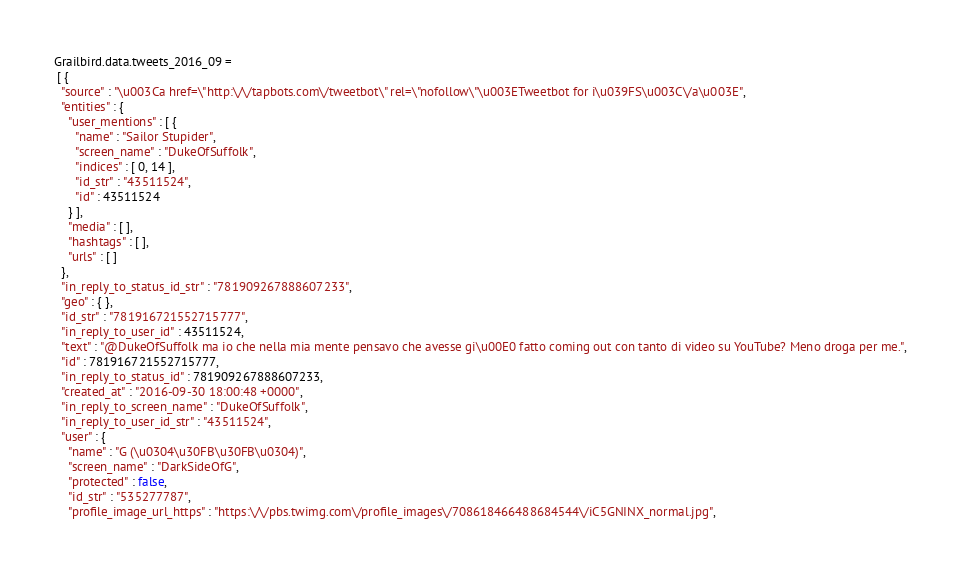<code> <loc_0><loc_0><loc_500><loc_500><_JavaScript_>Grailbird.data.tweets_2016_09 = 
 [ {
  "source" : "\u003Ca href=\"http:\/\/tapbots.com\/tweetbot\" rel=\"nofollow\"\u003ETweetbot for i\u039FS\u003C\/a\u003E",
  "entities" : {
    "user_mentions" : [ {
      "name" : "Sailor Stupider",
      "screen_name" : "DukeOfSuffolk",
      "indices" : [ 0, 14 ],
      "id_str" : "43511524",
      "id" : 43511524
    } ],
    "media" : [ ],
    "hashtags" : [ ],
    "urls" : [ ]
  },
  "in_reply_to_status_id_str" : "781909267888607233",
  "geo" : { },
  "id_str" : "781916721552715777",
  "in_reply_to_user_id" : 43511524,
  "text" : "@DukeOfSuffolk ma io che nella mia mente pensavo che avesse gi\u00E0 fatto coming out con tanto di video su YouTube? Meno droga per me.",
  "id" : 781916721552715777,
  "in_reply_to_status_id" : 781909267888607233,
  "created_at" : "2016-09-30 18:00:48 +0000",
  "in_reply_to_screen_name" : "DukeOfSuffolk",
  "in_reply_to_user_id_str" : "43511524",
  "user" : {
    "name" : "G (\u0304\u30FB\u30FB\u0304)",
    "screen_name" : "DarkSideOfG",
    "protected" : false,
    "id_str" : "535277787",
    "profile_image_url_https" : "https:\/\/pbs.twimg.com\/profile_images\/708618466488684544\/iC5GNINX_normal.jpg",</code> 